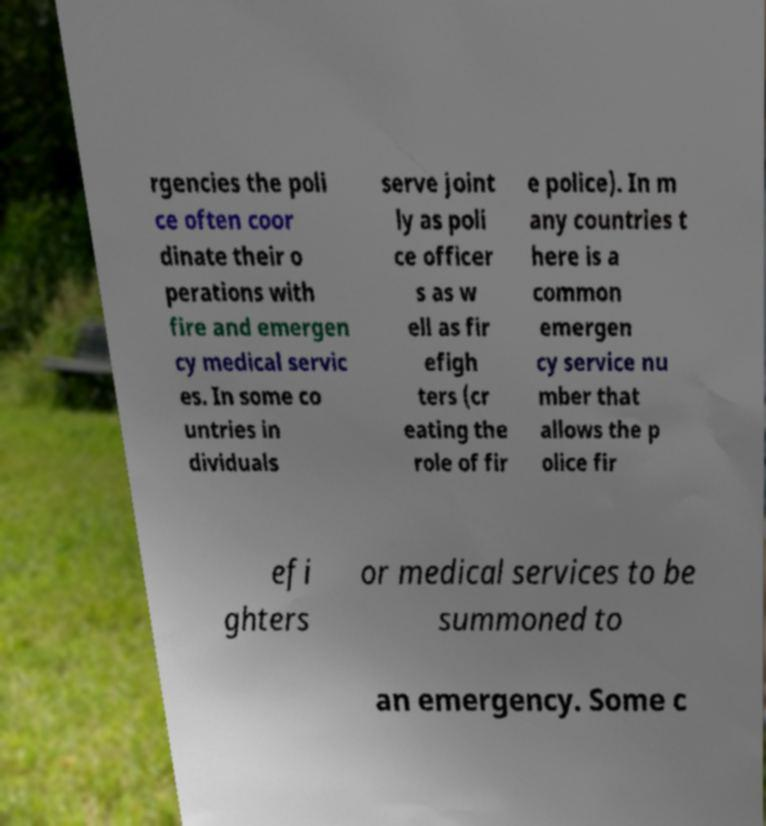Can you accurately transcribe the text from the provided image for me? rgencies the poli ce often coor dinate their o perations with fire and emergen cy medical servic es. In some co untries in dividuals serve joint ly as poli ce officer s as w ell as fir efigh ters (cr eating the role of fir e police). In m any countries t here is a common emergen cy service nu mber that allows the p olice fir efi ghters or medical services to be summoned to an emergency. Some c 